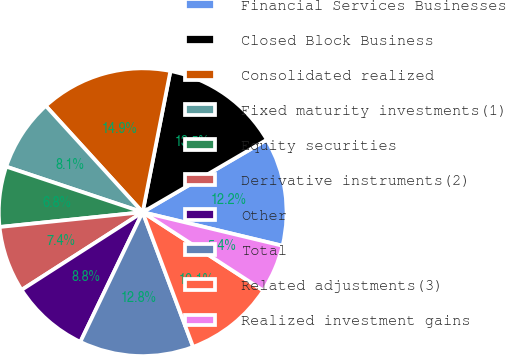Convert chart. <chart><loc_0><loc_0><loc_500><loc_500><pie_chart><fcel>Financial Services Businesses<fcel>Closed Block Business<fcel>Consolidated realized<fcel>Fixed maturity investments(1)<fcel>Equity securities<fcel>Derivative instruments(2)<fcel>Other<fcel>Total<fcel>Related adjustments(3)<fcel>Realized investment gains<nl><fcel>12.16%<fcel>13.5%<fcel>14.85%<fcel>8.11%<fcel>6.77%<fcel>7.44%<fcel>8.79%<fcel>12.83%<fcel>10.13%<fcel>5.42%<nl></chart> 